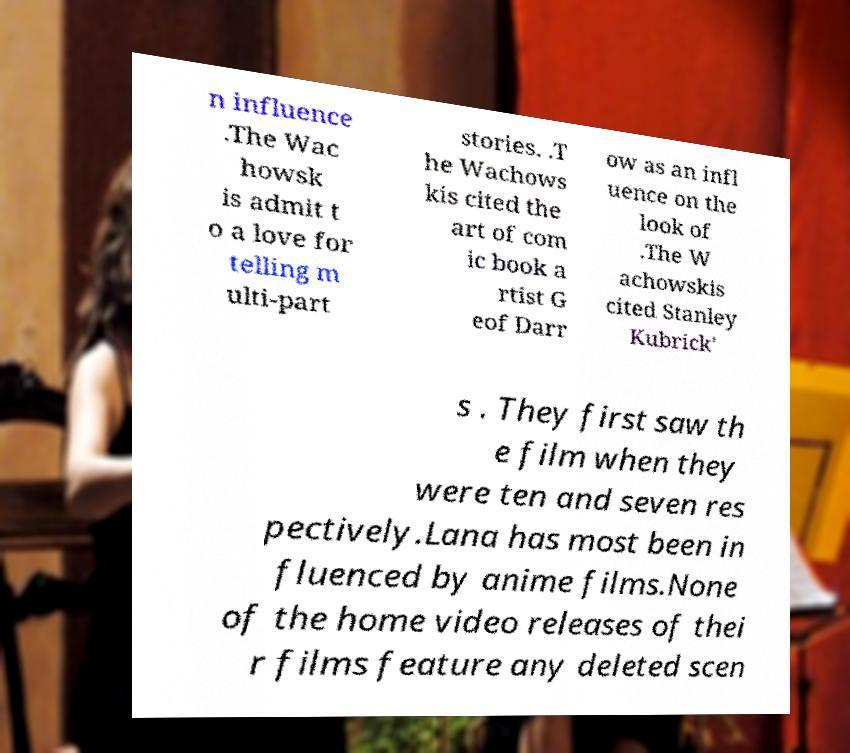Can you read and provide the text displayed in the image?This photo seems to have some interesting text. Can you extract and type it out for me? n influence .The Wac howsk is admit t o a love for telling m ulti-part stories. .T he Wachows kis cited the art of com ic book a rtist G eof Darr ow as an infl uence on the look of .The W achowskis cited Stanley Kubrick' s . They first saw th e film when they were ten and seven res pectively.Lana has most been in fluenced by anime films.None of the home video releases of thei r films feature any deleted scen 